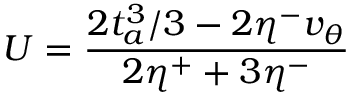Convert formula to latex. <formula><loc_0><loc_0><loc_500><loc_500>U = \frac { 2 t _ { a } ^ { 3 } / 3 - 2 \eta ^ { - } v _ { \theta } } { 2 \eta ^ { + } + 3 \eta ^ { - } }</formula> 